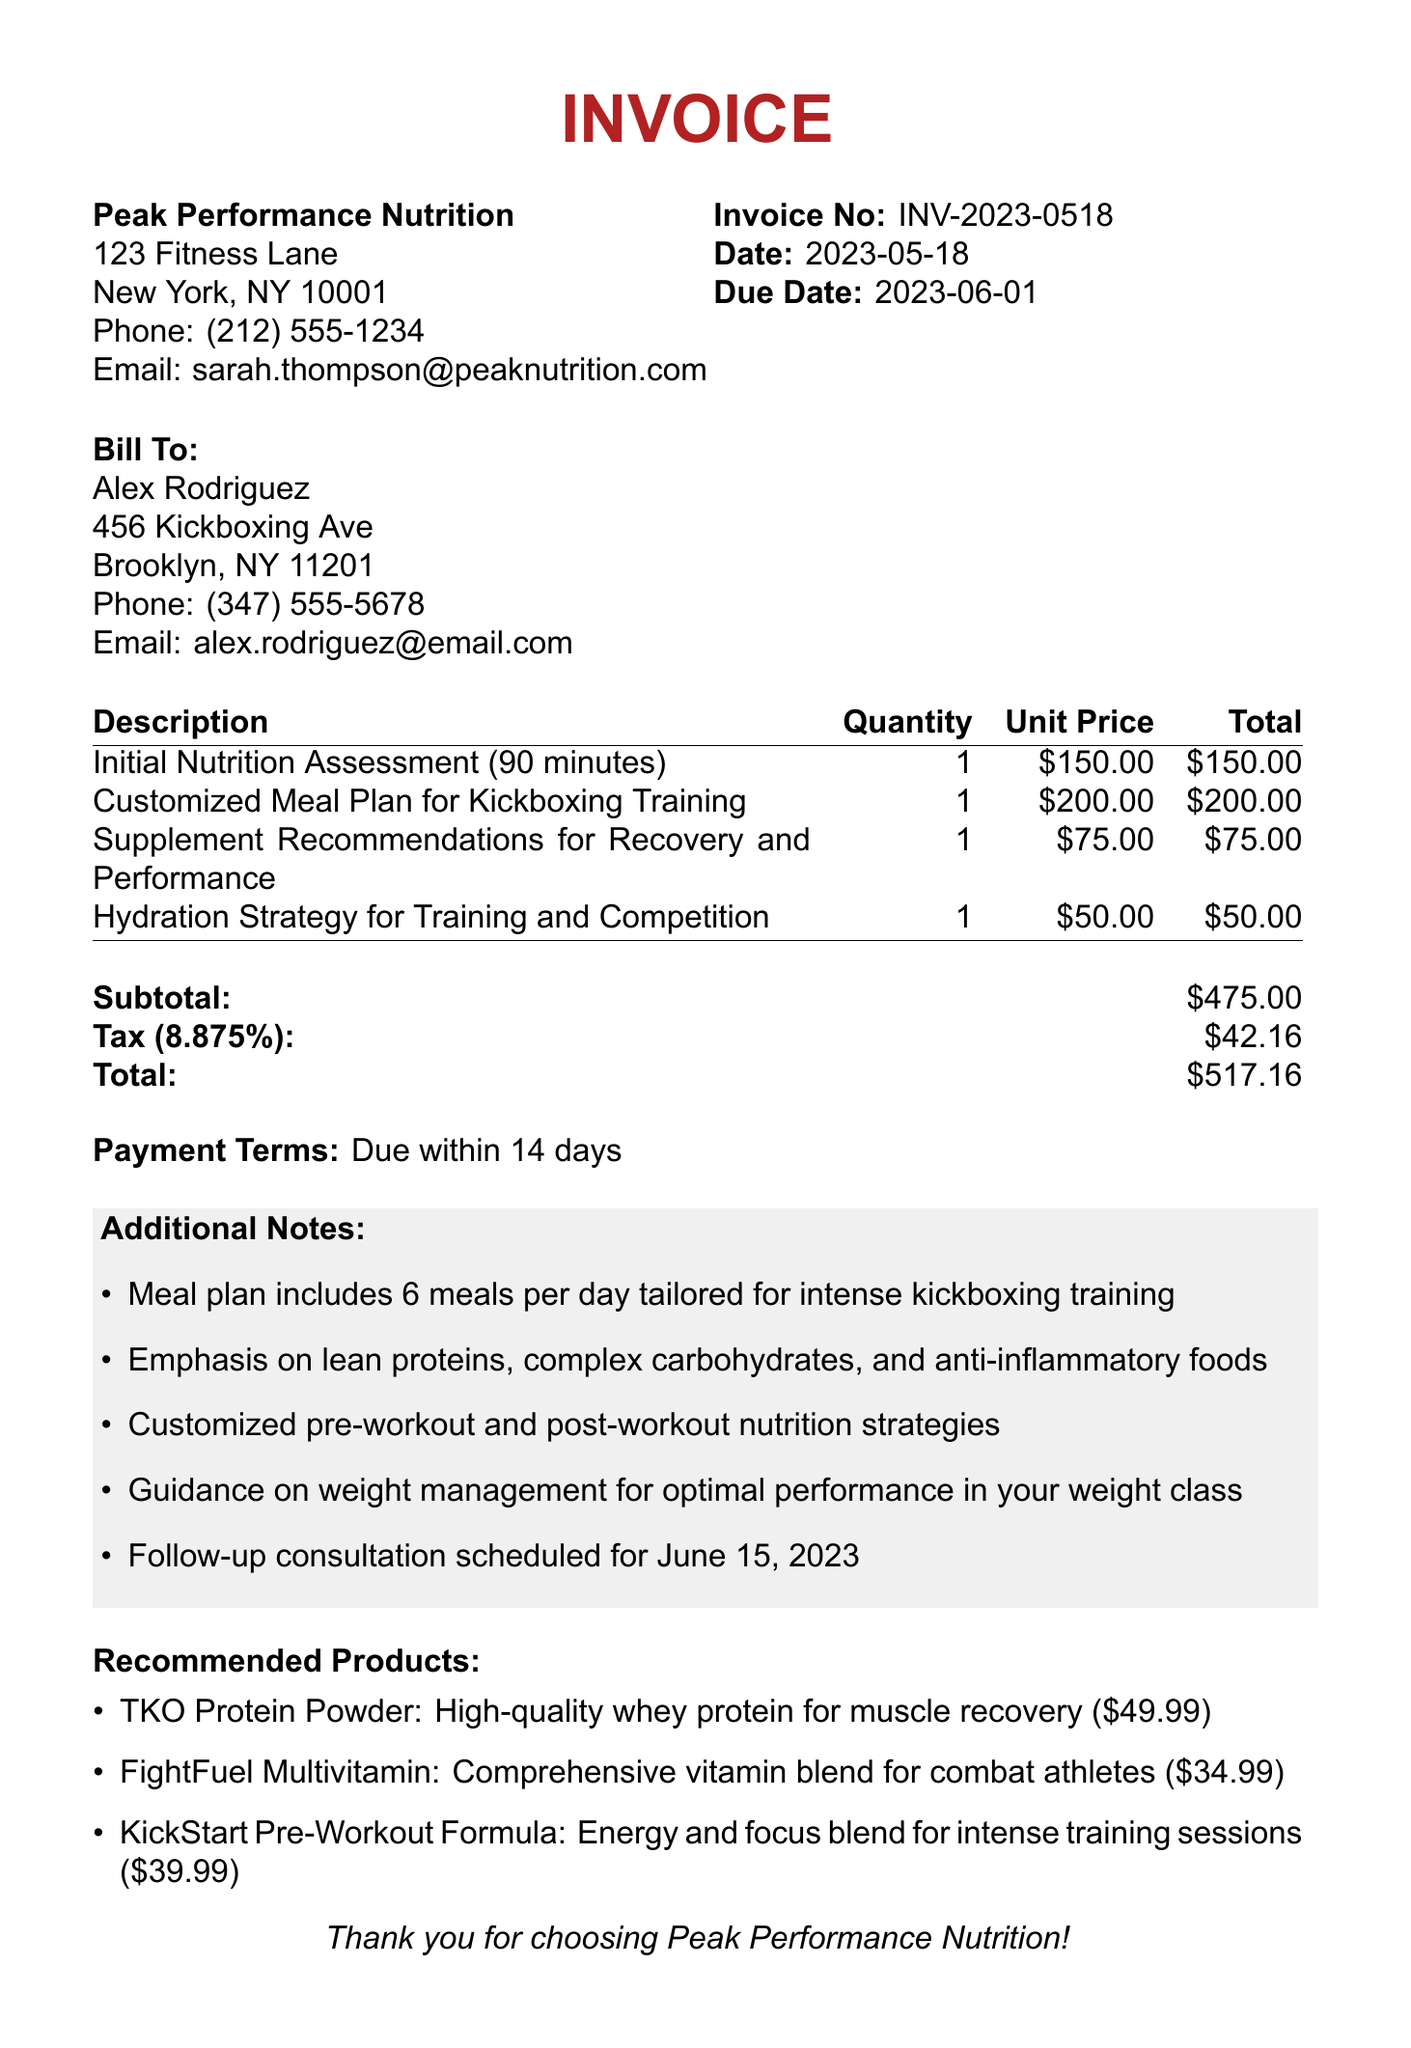What is the invoice number? The invoice number is explicitly stated in the document as part of the invoice details.
Answer: INV-2023-0518 Who is the nutritionist? The document specifies the name of the nutritionist providing the services.
Answer: Dr. Sarah Thompson What is the due date for payment? The due date is clearly mentioned in the invoice details section.
Answer: 2023-06-01 How much is the total amount due? The total amount is calculated at the end of the invoice, summarizing the costs.
Answer: $517.16 What is included in the customized meal plan? The additional notes detail what the meal plan consists of, specifically for kickboxers.
Answer: 6 meals per day tailored for intense kickboxing training How many services are listed in total? The total number of services can be counted from the services section of the invoice.
Answer: 4 What is the tax rate applied? The tax rate is stated in the summary of fees at the bottom of the invoice.
Answer: 8.875% What are the recommended products? The recommended products section lists specific items with their descriptions and prices.
Answer: TKO Protein Powder, FightFuel Multivitamin, KickStart Pre-Workout Formula What is the contact email for the nutritionist? The email address is provided among the nutritionist's contact details.
Answer: sarah.thompson@peaknutrition.com 